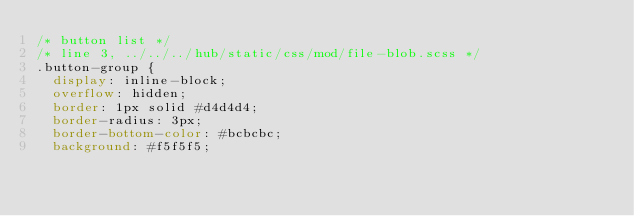<code> <loc_0><loc_0><loc_500><loc_500><_CSS_>/* button list */
/* line 3, ../../../hub/static/css/mod/file-blob.scss */
.button-group {
  display: inline-block;
  overflow: hidden;
  border: 1px solid #d4d4d4;
  border-radius: 3px;
  border-bottom-color: #bcbcbc;
  background: #f5f5f5;</code> 